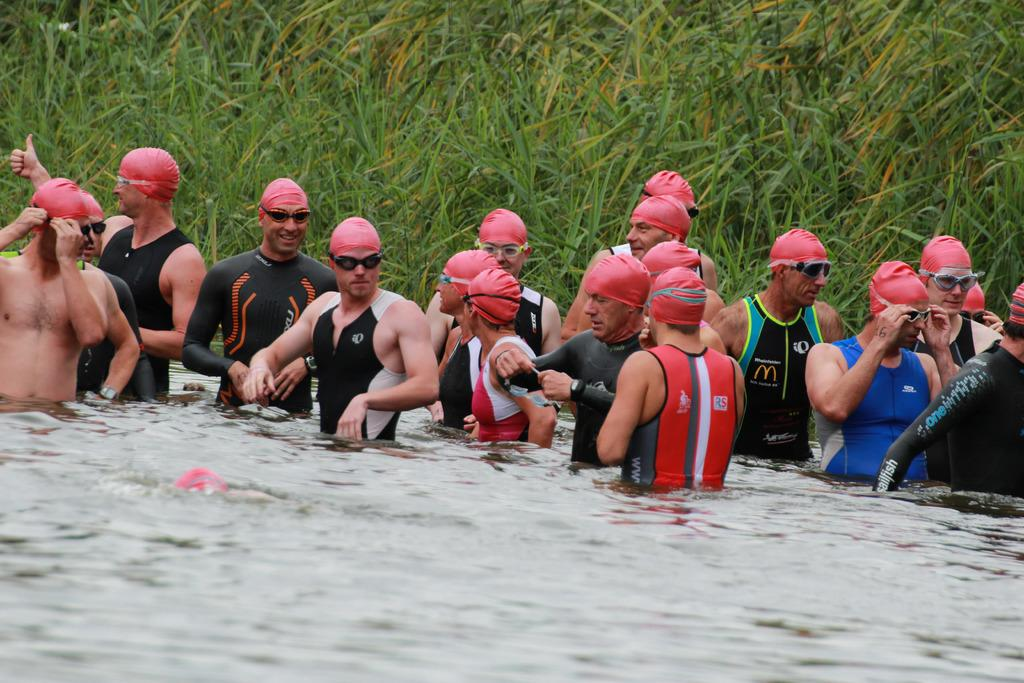What are the people in the image doing? The people in the image are standing in the water. What accessories are the people wearing? The people are wearing swimming caps and goggles. What can be seen in the background of the image? There are plants visible in the background of the image. How many flowers can be seen in the image? There are no flowers visible in the image; it features people standing in the water with plants in the background. 